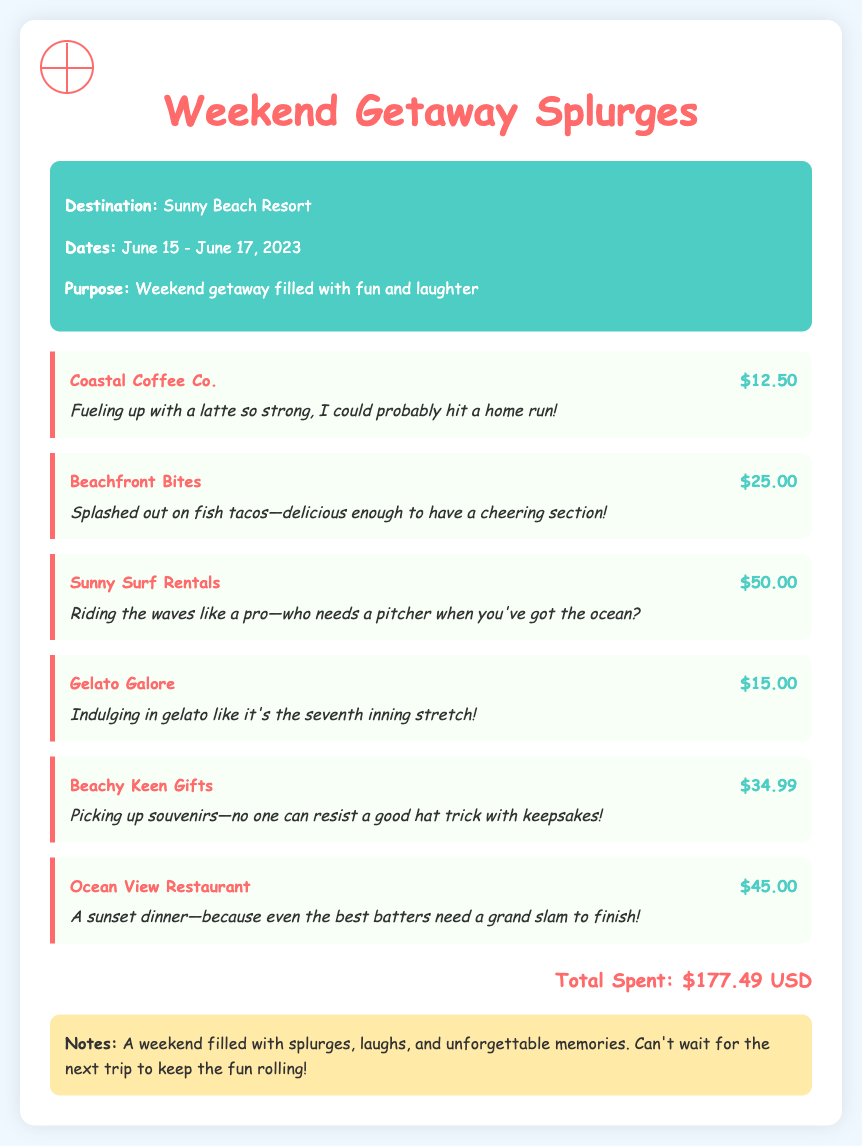What was the total amount spent during the trip? The total amount spent is explicitly stated in the document in the total section.
Answer: $177.49 USD Who did the group buy gelato from? The merchant for gelato is listed in the transactions section of the document.
Answer: Gelato Galore What activity cost the most during the weekend? To find the most expensive activity, we look at the transaction amounts and identify the highest one.
Answer: Sunny Surf Rentals When did the weekend getaway take place? The dates of the weekend getaway are mentioned in the trip summary of the document.
Answer: June 15 - June 17, 2023 What was purchased at Beachfront Bites? The description for the transaction at Beachfront Bites is provided in the document.
Answer: fish tacos What is noted as a key sentiment of the trip? The notes section summarizes how the trip was perceived, focusing on the overall experience.
Answer: unforgettable memories 